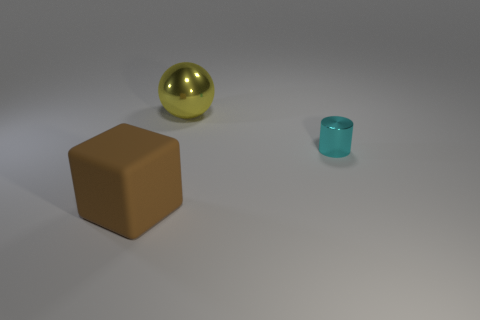Add 1 tiny blue metallic cylinders. How many objects exist? 4 Subtract 0 green blocks. How many objects are left? 3 Subtract all big brown rubber cubes. Subtract all tiny things. How many objects are left? 1 Add 1 tiny cyan things. How many tiny cyan things are left? 2 Add 3 balls. How many balls exist? 4 